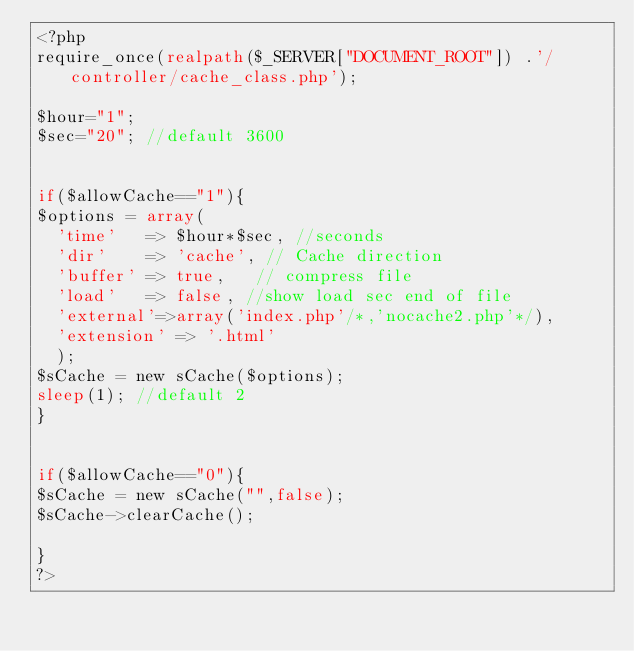<code> <loc_0><loc_0><loc_500><loc_500><_PHP_><?php 
require_once(realpath($_SERVER["DOCUMENT_ROOT"]) .'/controller/cache_class.php');

$hour="1";
$sec="20"; //default 3600


if($allowCache=="1"){
$options = array(
	'time'   => $hour*$sec, //seconds
	'dir'    => 'cache', // Cache direction
	'buffer' => true,   // compress file
	'load'   => false, //show load sec end of file
	'external'=>array('index.php'/*,'nocache2.php'*/),
	'extension' => '.html' 
	);
$sCache = new sCache($options);
sleep(1); //default 2
} 


if($allowCache=="0"){
$sCache = new sCache("",false);
$sCache->clearCache();

}
?></code> 